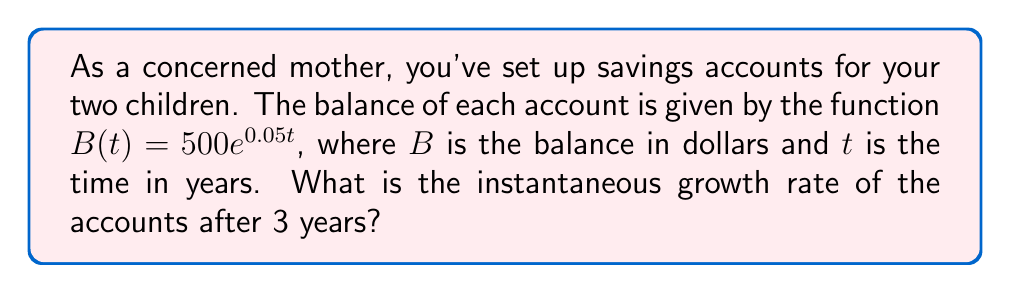Show me your answer to this math problem. To find the instantaneous growth rate, we need to calculate the derivative of the balance function and evaluate it at $t=3$. Here's how we do it step-by-step:

1) The given function is $B(t) = 500e^{0.05t}$

2) To find the derivative, we use the chain rule:
   $B'(t) = 500 \cdot (e^{0.05t})' = 500 \cdot 0.05e^{0.05t}$

3) Simplify:
   $B'(t) = 25e^{0.05t}$

4) This derivative represents the instantaneous growth rate at any time $t$.

5) To find the growth rate after 3 years, we evaluate $B'(3)$:
   $B'(3) = 25e^{0.05(3)} = 25e^{0.15}$

6) Calculate:
   $B'(3) \approx 28.96$

Therefore, the instantaneous growth rate after 3 years is approximately $28.96 per year.
Answer: $28.96 per year 